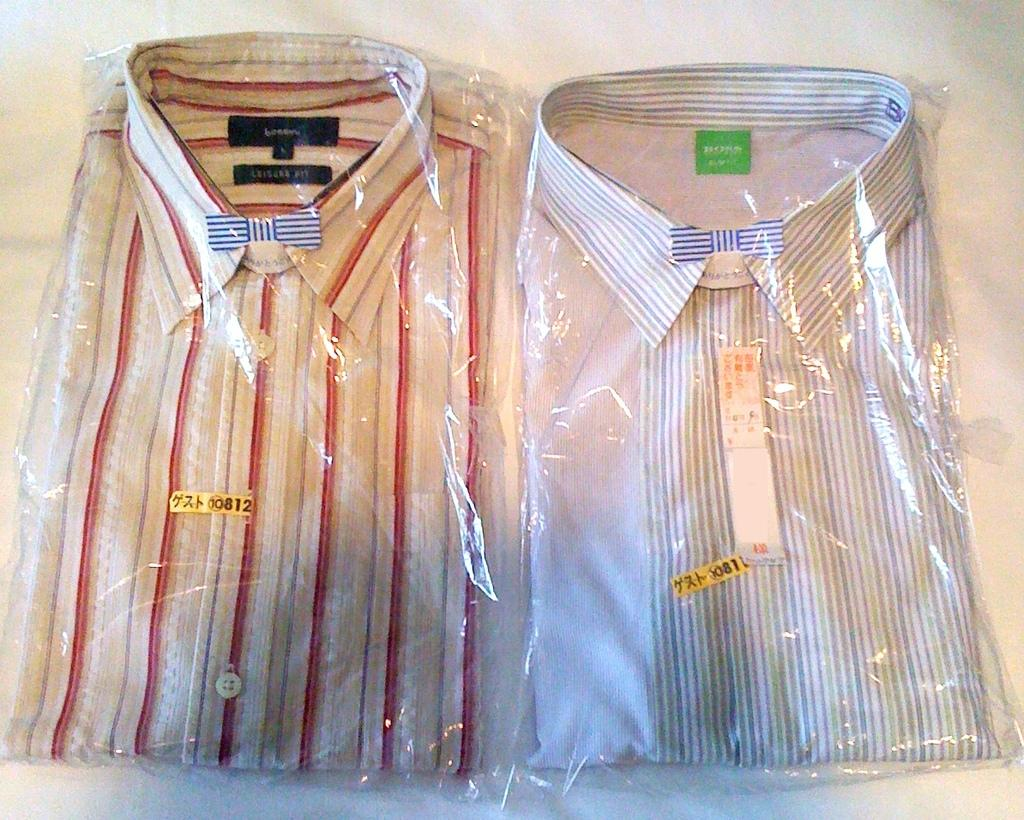What objects are present in the image? There are two folded shirts in the image. How are the shirts being stored or protected? The shirts are wrapped in a plastic cover. What type of toy can be seen playing with the sand in the image? There is no toy or sand present in the image; it only features two folded shirts wrapped in a plastic cover. How many pets are visible in the image? There are no pets visible in the image; it only features two folded shirts wrapped in a plastic cover. 